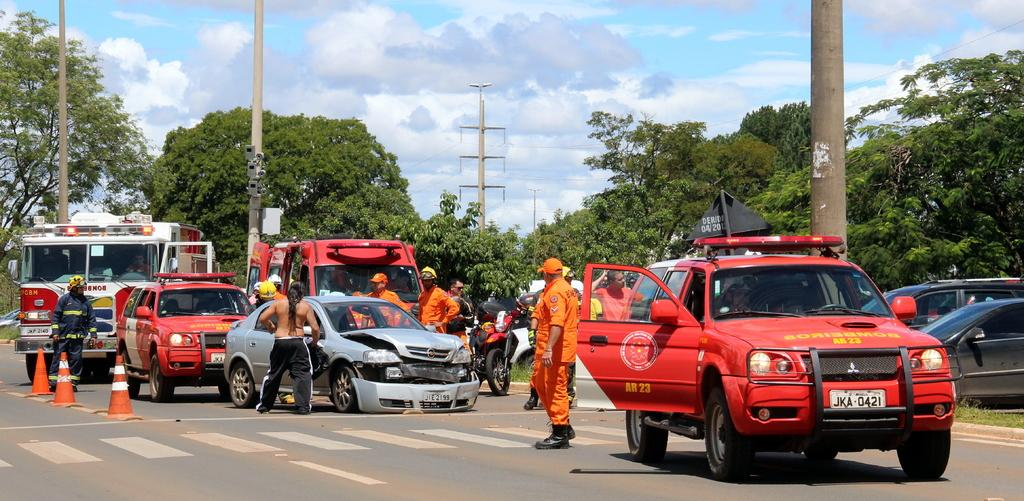What can be seen in the background of the image? There is a sky in the image, with clouds visible. What type of natural elements are present in the image? There are trees in the image. What is happening on the road in the image? There are vehicles on the road in the image. Are there any people present in the image? Yes, there are people standing in the image. What object is used to direct traffic in the image? There is a traffic cone in the image. What type of ticket is being sold at the volleyball game in the image? There is no volleyball game or ticket sales present in the image. Can you tell me how many sinks are visible in the image? There are no sinks visible in the image. 